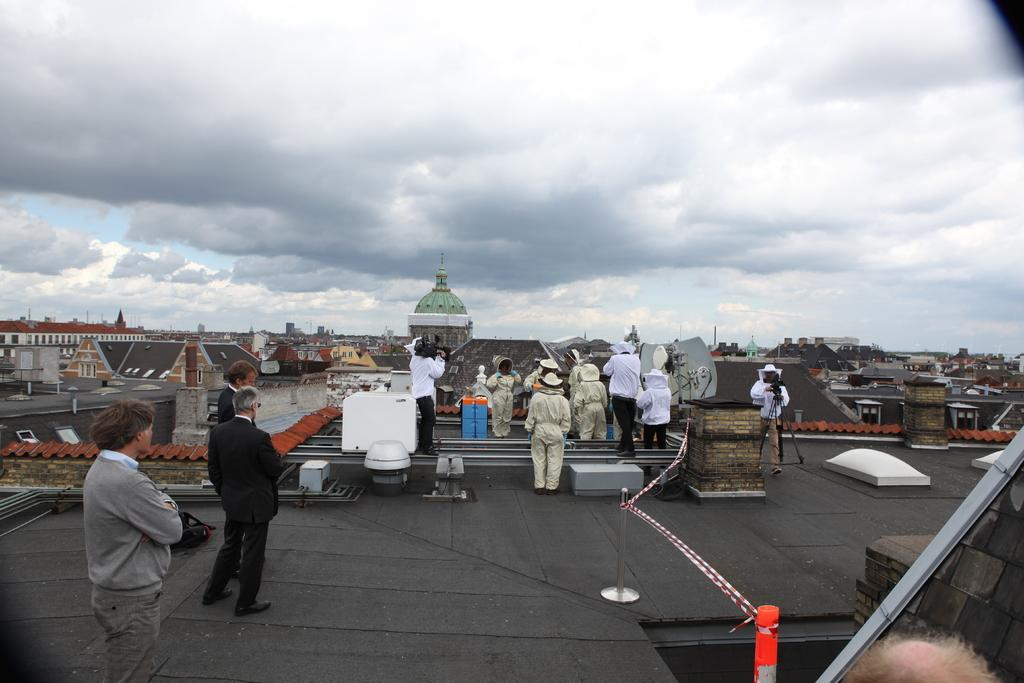Who or what can be seen in the image? There are people in the image. What type of structures are visible in the image? There are houses in the image. What is visible at the top of the image? The sky is visible at the top of the image. What can be observed in the sky? Clouds are present in the sky. What type of insect can be seen crawling on the roof of the house in the image? There is no insect present on the roof of the house in the image. 